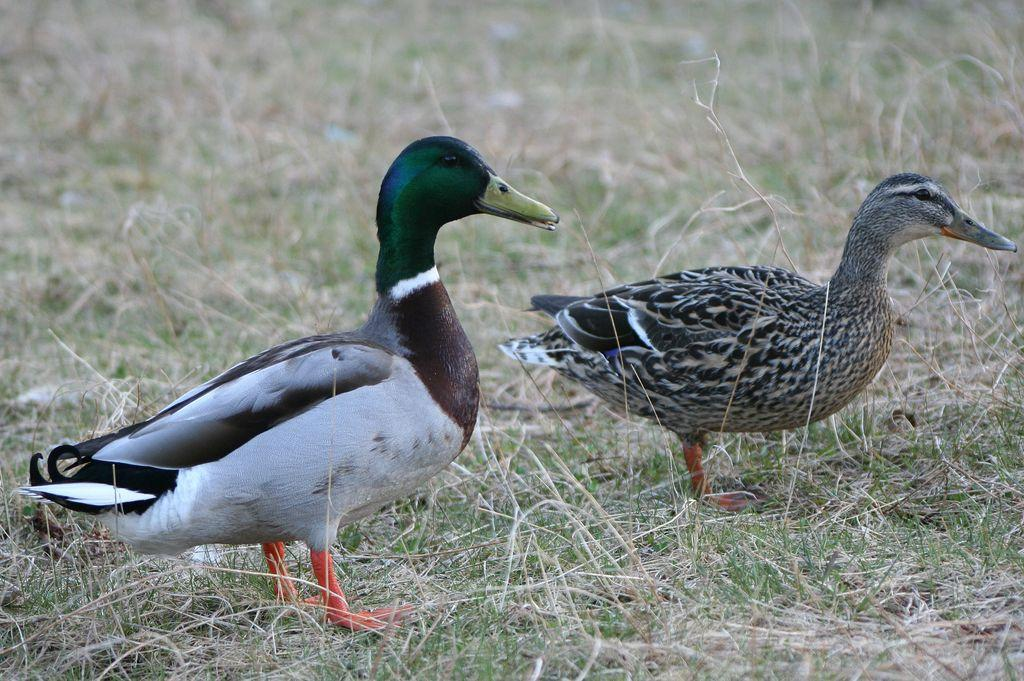What animals are present in the image? There are two ducks in the image. Where are the ducks located? The ducks are on the grassland. Can you see a kitten playing with an iron on the grassland in the image? No, there is no kitten or iron present in the image; it only features two ducks on the grassland. 